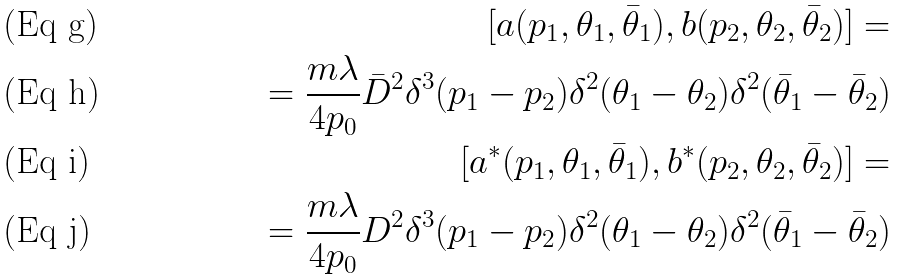Convert formula to latex. <formula><loc_0><loc_0><loc_500><loc_500>[ a ( p _ { 1 } , \theta _ { 1 } , \bar { \theta } _ { 1 } ) , b ( p _ { 2 } , \theta _ { 2 } , \bar { \theta } _ { 2 } ) ] = \\ = \frac { m \lambda } { 4 p _ { 0 } } \bar { D } ^ { 2 } \delta ^ { 3 } ( p _ { 1 } - p _ { 2 } ) \delta ^ { 2 } ( \theta _ { 1 } - \theta _ { 2 } ) \delta ^ { 2 } ( \bar { \theta } _ { 1 } - \bar { \theta } _ { 2 } ) \\ [ a ^ { * } ( p _ { 1 } , \theta _ { 1 } , \bar { \theta } _ { 1 } ) , b ^ { * } ( p _ { 2 } , \theta _ { 2 } , \bar { \theta } _ { 2 } ) ] = \\ = \frac { m \lambda } { 4 p _ { 0 } } D ^ { 2 } \delta ^ { 3 } ( p _ { 1 } - p _ { 2 } ) \delta ^ { 2 } ( \theta _ { 1 } - \theta _ { 2 } ) \delta ^ { 2 } ( \bar { \theta } _ { 1 } - \bar { \theta } _ { 2 } )</formula> 